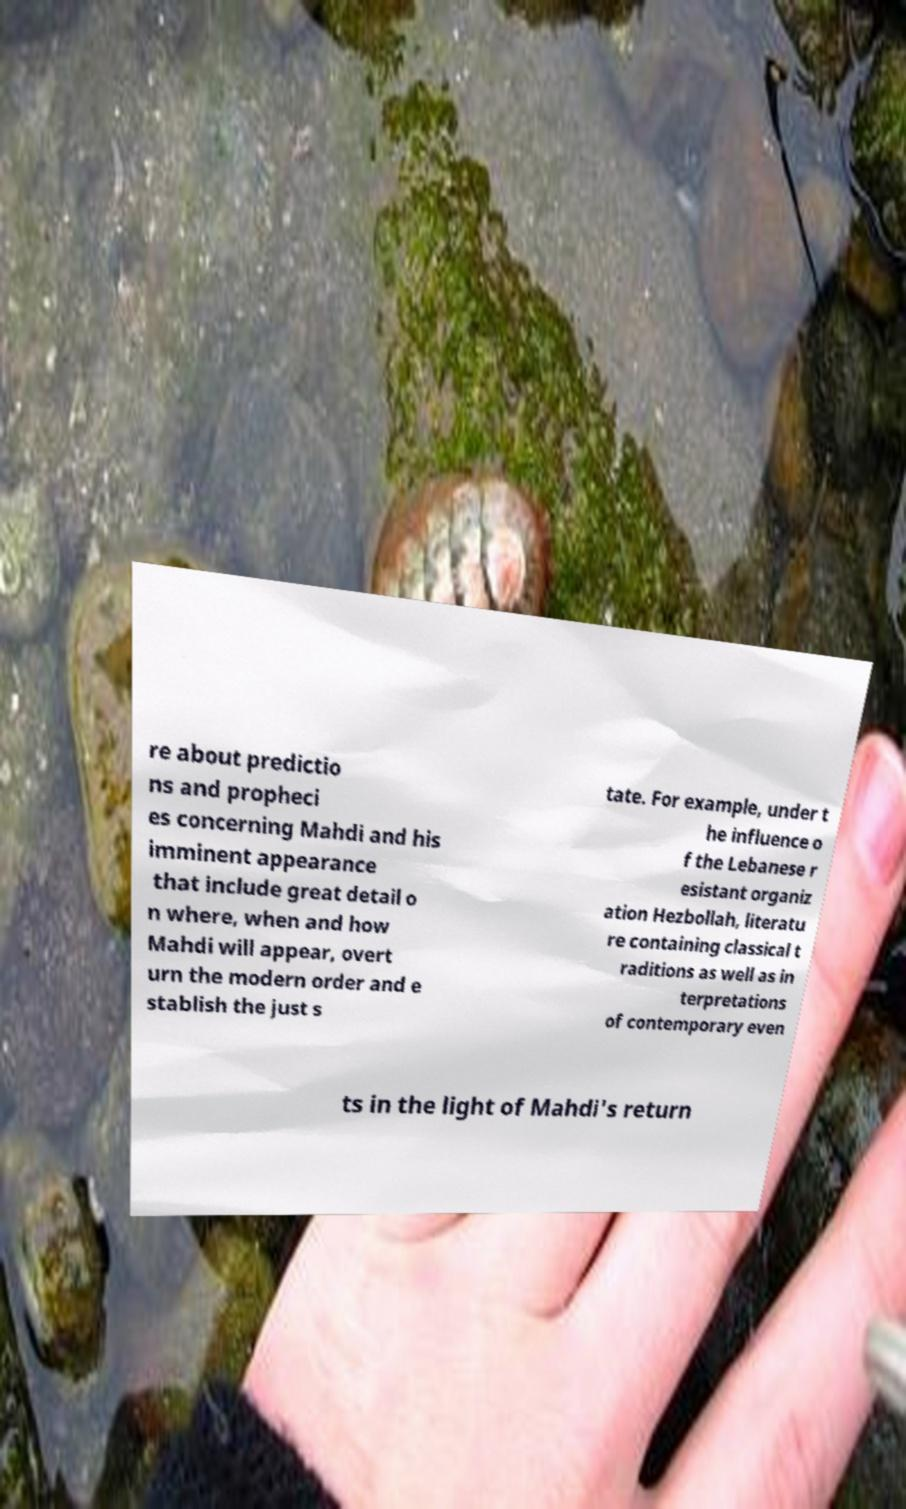I need the written content from this picture converted into text. Can you do that? re about predictio ns and propheci es concerning Mahdi and his imminent appearance that include great detail o n where, when and how Mahdi will appear, overt urn the modern order and e stablish the just s tate. For example, under t he influence o f the Lebanese r esistant organiz ation Hezbollah, literatu re containing classical t raditions as well as in terpretations of contemporary even ts in the light of Mahdi's return 